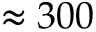<formula> <loc_0><loc_0><loc_500><loc_500>\approx 3 0 0</formula> 